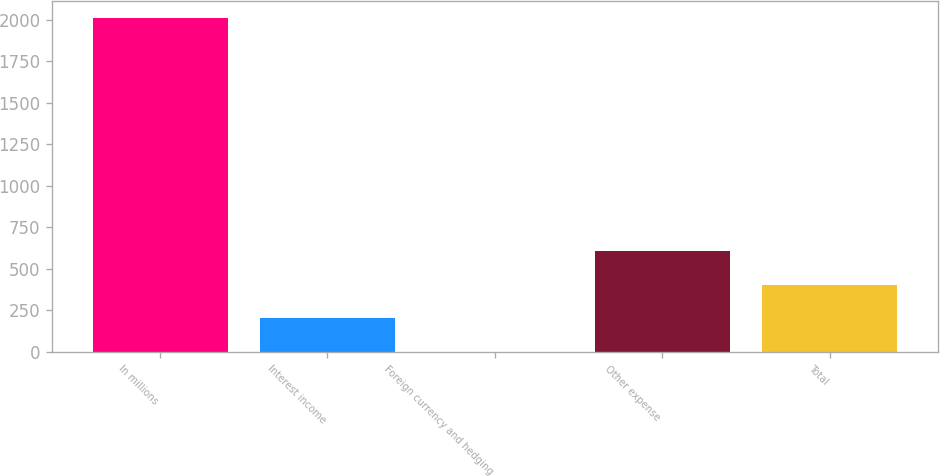Convert chart to OTSL. <chart><loc_0><loc_0><loc_500><loc_500><bar_chart><fcel>In millions<fcel>Interest income<fcel>Foreign currency and hedging<fcel>Other expense<fcel>Total<nl><fcel>2010<fcel>202.8<fcel>2<fcel>604.4<fcel>403.6<nl></chart> 